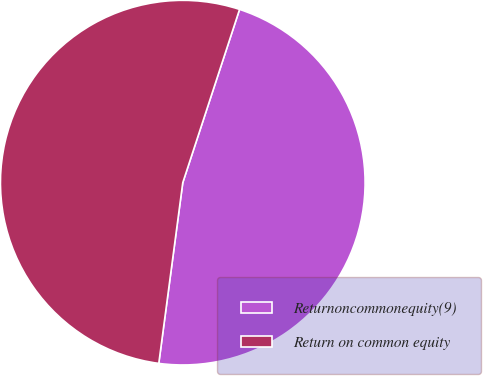<chart> <loc_0><loc_0><loc_500><loc_500><pie_chart><fcel>Returnoncommonequity(9)<fcel>Return on common equity<nl><fcel>47.06%<fcel>52.94%<nl></chart> 